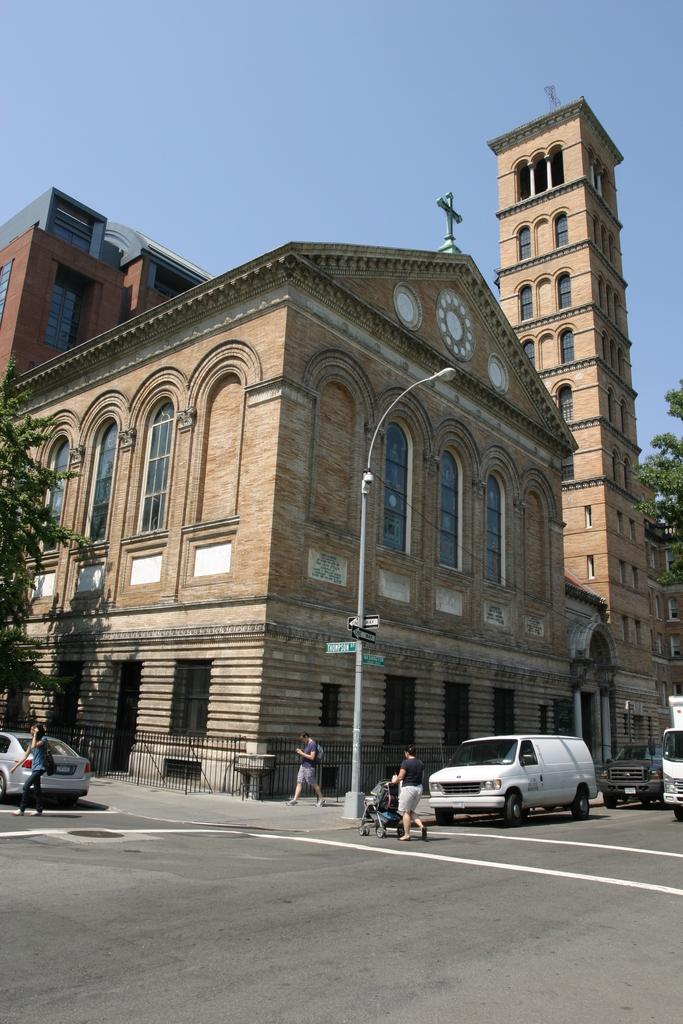What type of structures can be seen in the image? There are buildings in the image. What else can be seen in the image besides buildings? There are poles, trees, vehicles parked, and a road visible in the image. Can you describe the vehicles in the image? The vehicles are parked, but their specific types cannot be determined from the image. What is the purpose of the poles in the image? The purpose of the poles cannot be determined from the image, but they may be used for streetlights, signs, or other utilities. What type of crate is being used to transport the gold in the image? There is no crate or gold present in the image. What color is the ring on the tree in the image? There is no ring present in the image. 